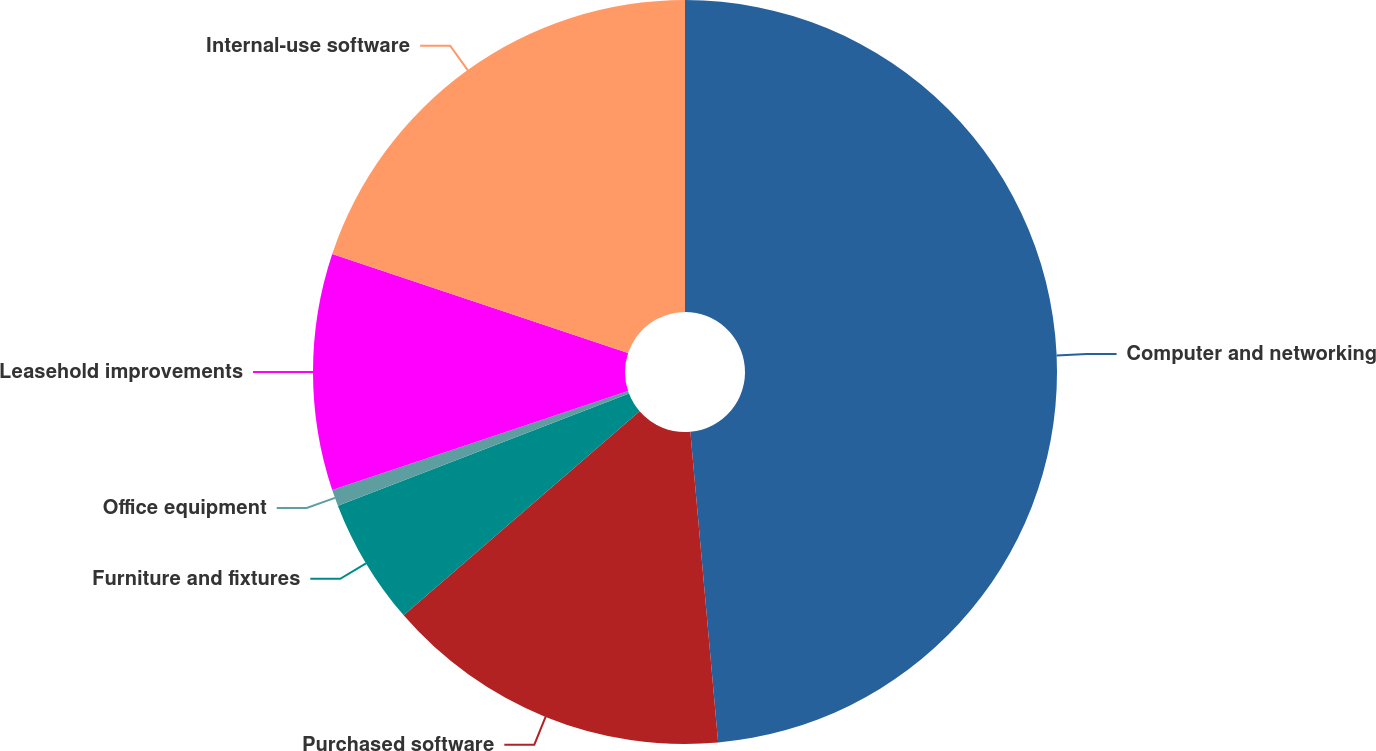Convert chart to OTSL. <chart><loc_0><loc_0><loc_500><loc_500><pie_chart><fcel>Computer and networking<fcel>Purchased software<fcel>Furniture and fixtures<fcel>Office equipment<fcel>Leasehold improvements<fcel>Internal-use software<nl><fcel>48.58%<fcel>15.07%<fcel>5.5%<fcel>0.71%<fcel>10.28%<fcel>19.86%<nl></chart> 